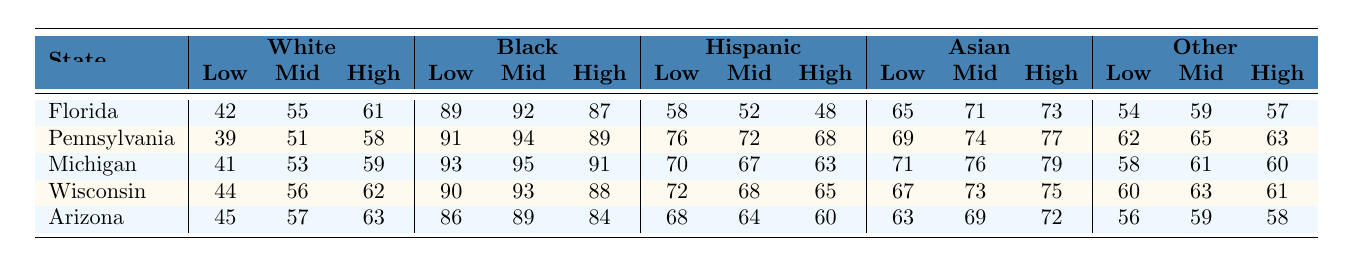What is the voting percentage of low-income Black voters in Michigan? In Michigan, the voting percentage for low-income Black voters is listed in the table under the Black column for Low Income, which shows 93%.
Answer: 93% Which state has the highest voting percentage for low-income Hispanic voters? The table indicates that in Pennsylvania, the voting percentage for low-income Hispanic voters is 76%, which is the highest among all listed states.
Answer: Pennsylvania What is the difference between the high-income voting percentages for White and Black voters in Florida? In Florida, the high-income voting percentage for White voters is 61%, and for Black voters, it is 87%. The difference is 87% - 61% = 26%.
Answer: 26% What is the average voting percentage of low-income Asian voters across all states? Adding the low-income voting percentages for Asian voters from all states gives (65 + 69 + 71 + 67 + 63) = 335. There are 5 states, so the average is 335/5 = 67%.
Answer: 67% True or False: The high-income voting percentage for Hispanic voters is higher in Arizona than in Michigan. In Arizona, the high-income voting percentage for Hispanic voters is 60%, while in Michigan, it is 63%. Since 60% is not higher than 63%, the answer is False.
Answer: False Which racial group has the lowest voting percentage among low-income voters in Pennsylvania? By checking the low-income voting percentages in Pennsylvania, Black voters have the highest (91%), followed by Hispanic (76%), Asian (69%), White (39%), and Other (62%). White has the lowest percentage among the groups, which is 39%.
Answer: White In which state do high-income Asian voters have the highest voting percentage? The table shows high-income voting percentages for Asian voters in all states: 73% in Florida, 79% in Michigan, 75% in Wisconsin, 72% in Arizona. The highest percentage is 79% in Michigan.
Answer: Michigan What is the overall trend in voting percentages for low-income voters across racial groups in Wisconsin? In Wisconsin, looking at the low-income voter percentages: White 44%, Black 90%, Hispanic 72%, Asian 67%, Other 60%. The trend shows that Black voters have the highest percentage while White voters have the lowest among the racial groups.
Answer: Black voters have the highest How much lower is the voting percentage of low-income White voters in Arizona compared to Florida? In Arizona, low-income White voter percentage is 45%, while in Florida, it is 42%. The difference is 45% - 42% = 3%.
Answer: 3% What is the percentage of high-income Hispanic voters in Pennsylvania? The high-income voting percentage for Hispanic voters in Pennsylvania is found in the Hispanic High column, which shows 68%.
Answer: 68% 